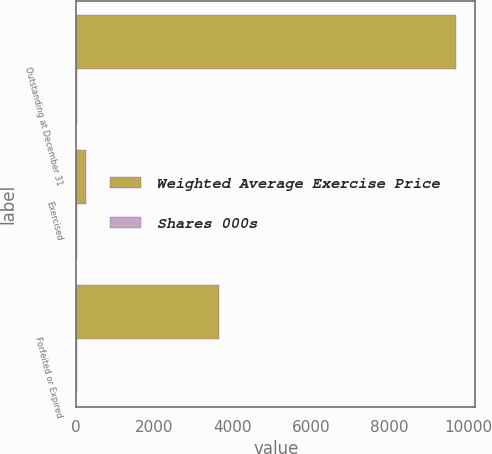Convert chart. <chart><loc_0><loc_0><loc_500><loc_500><stacked_bar_chart><ecel><fcel>Outstanding at December 31<fcel>Exercised<fcel>Forfeited or Expired<nl><fcel>Weighted Average Exercise Price<fcel>9705<fcel>257<fcel>3635<nl><fcel>Shares 000s<fcel>32.68<fcel>16.16<fcel>29.77<nl></chart> 